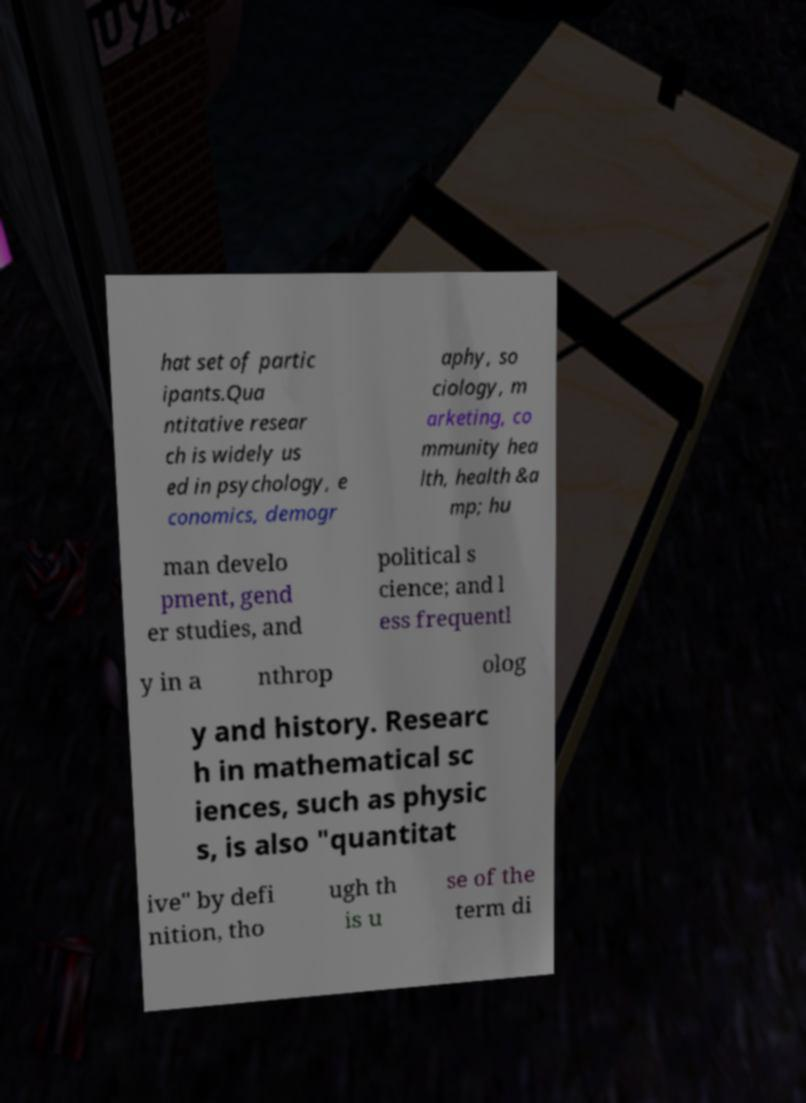Please identify and transcribe the text found in this image. hat set of partic ipants.Qua ntitative resear ch is widely us ed in psychology, e conomics, demogr aphy, so ciology, m arketing, co mmunity hea lth, health &a mp; hu man develo pment, gend er studies, and political s cience; and l ess frequentl y in a nthrop olog y and history. Researc h in mathematical sc iences, such as physic s, is also "quantitat ive" by defi nition, tho ugh th is u se of the term di 